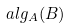<formula> <loc_0><loc_0><loc_500><loc_500>a l g _ { A } ( B )</formula> 